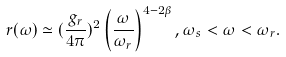<formula> <loc_0><loc_0><loc_500><loc_500>r ( \omega ) \simeq ( \frac { g _ { r } } { 4 \pi } ) ^ { 2 } \left ( \frac { \omega } { \omega _ { r } } \right ) ^ { 4 - 2 \beta } , \omega _ { s } < \omega < \omega _ { r } .</formula> 